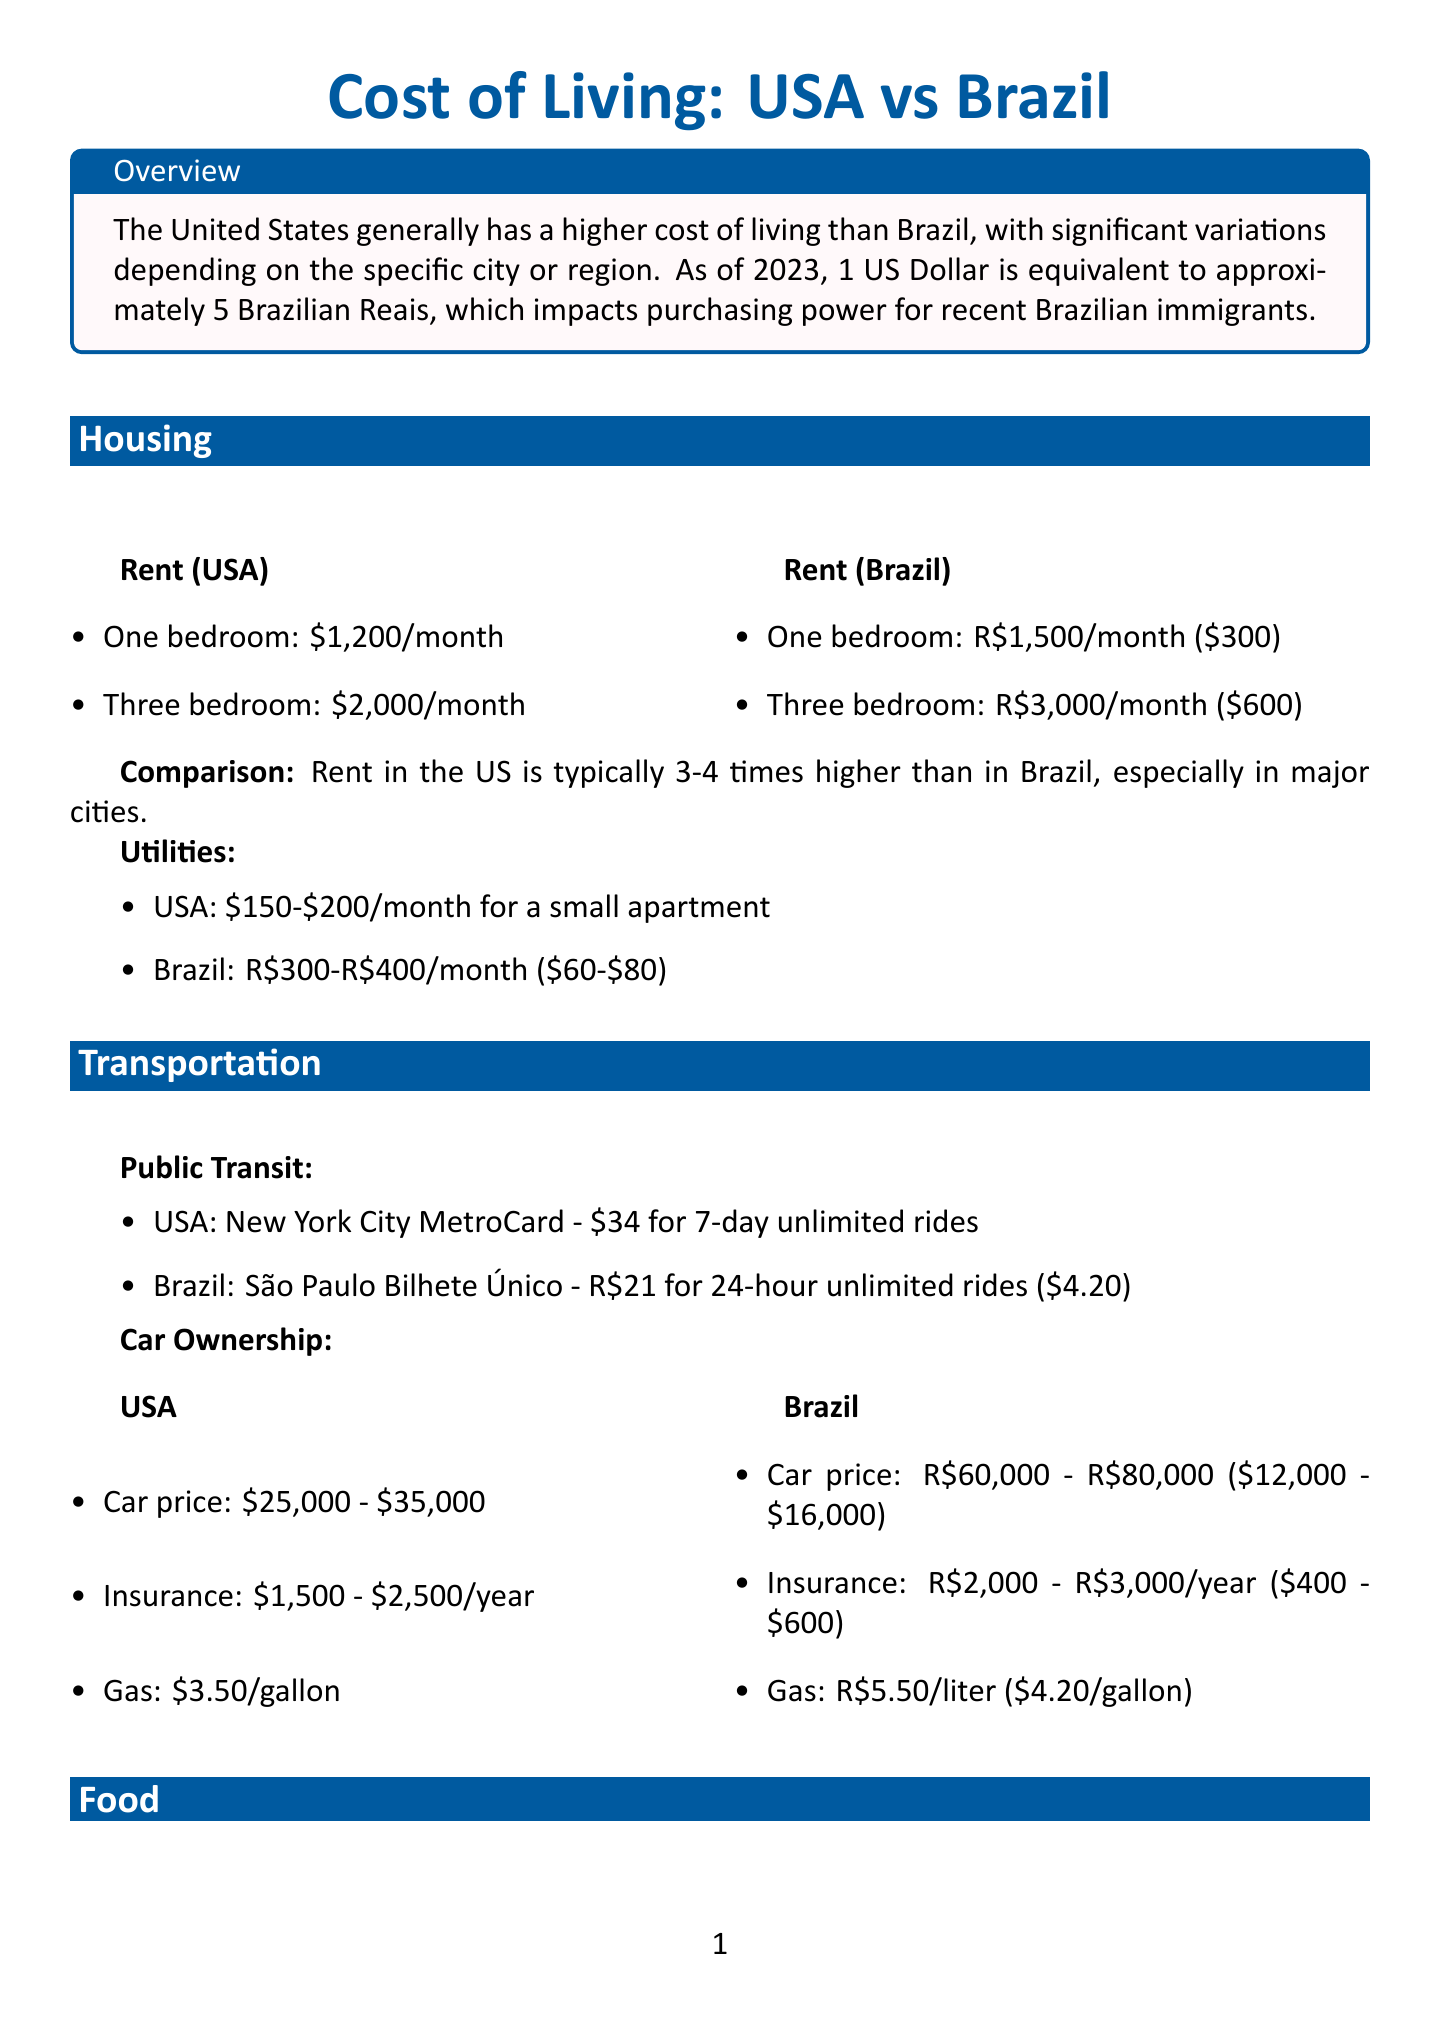What is the average rent for a one-bedroom apartment in the US? The document states the average rent for a one-bedroom apartment in the US is $1,200 per month.
Answer: $1,200 How much does public transportation cost in New York City for unlimited rides? The document mentions the cost of a New York City MetroCard for unlimited rides is $34 for 7 days.
Answer: $34 What is the average annual car insurance cost in the US? The average car insurance cost in the US is stated to be between $1,500 and $2,500 per year.
Answer: $1,500 - $2,500 Which country has a higher average cost for dining out at mid-range restaurants? The document indicates that dining out in the US is generally more expensive than in Brazil, especially for mid-range restaurants.
Answer: US What are the food prices for chicken per pound in the US? The average price for chicken in the US is listed as $3.50 per pound.
Answer: $3.50 What is the cost of private university per year in Brazil? The document shows the cost for private universities in Brazil is R$20,000 to R$50,000 per year.
Answer: R$20,000 - R$50,000 What is the comparison of grocery prices between the US and Brazil? The document states that grocery prices in the US are generally similar or slightly higher than in Brazil.
Answer: Similar or slightly higher How much is a movie ticket in the US? The average cost of a movie ticket in the US is between $12 and $15.
Answer: $12 - $15 What is the healthcare system like in Brazil compared to the US? The document describes Brazil's healthcare system as primarily public and free through the Sistema Único de Saúde (SUS), while the US system is more privatized and significantly more expensive.
Answer: Public and free vs privatized and expensive 